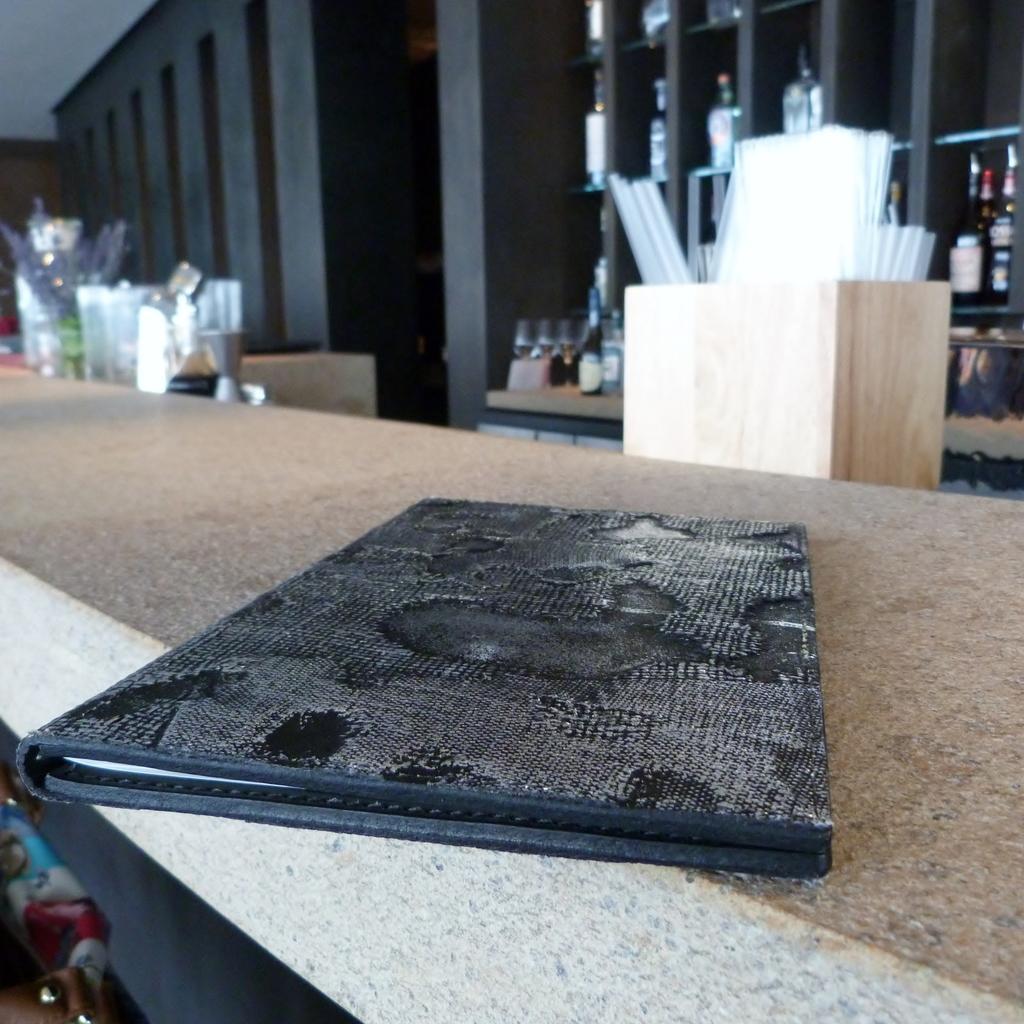Please provide a concise description of this image. In the foreground of the picture there is a file on the desk. On the right there are bottles in shelves and there is a wooden object in it there are some white things. On the left there are shelves and some objects. 